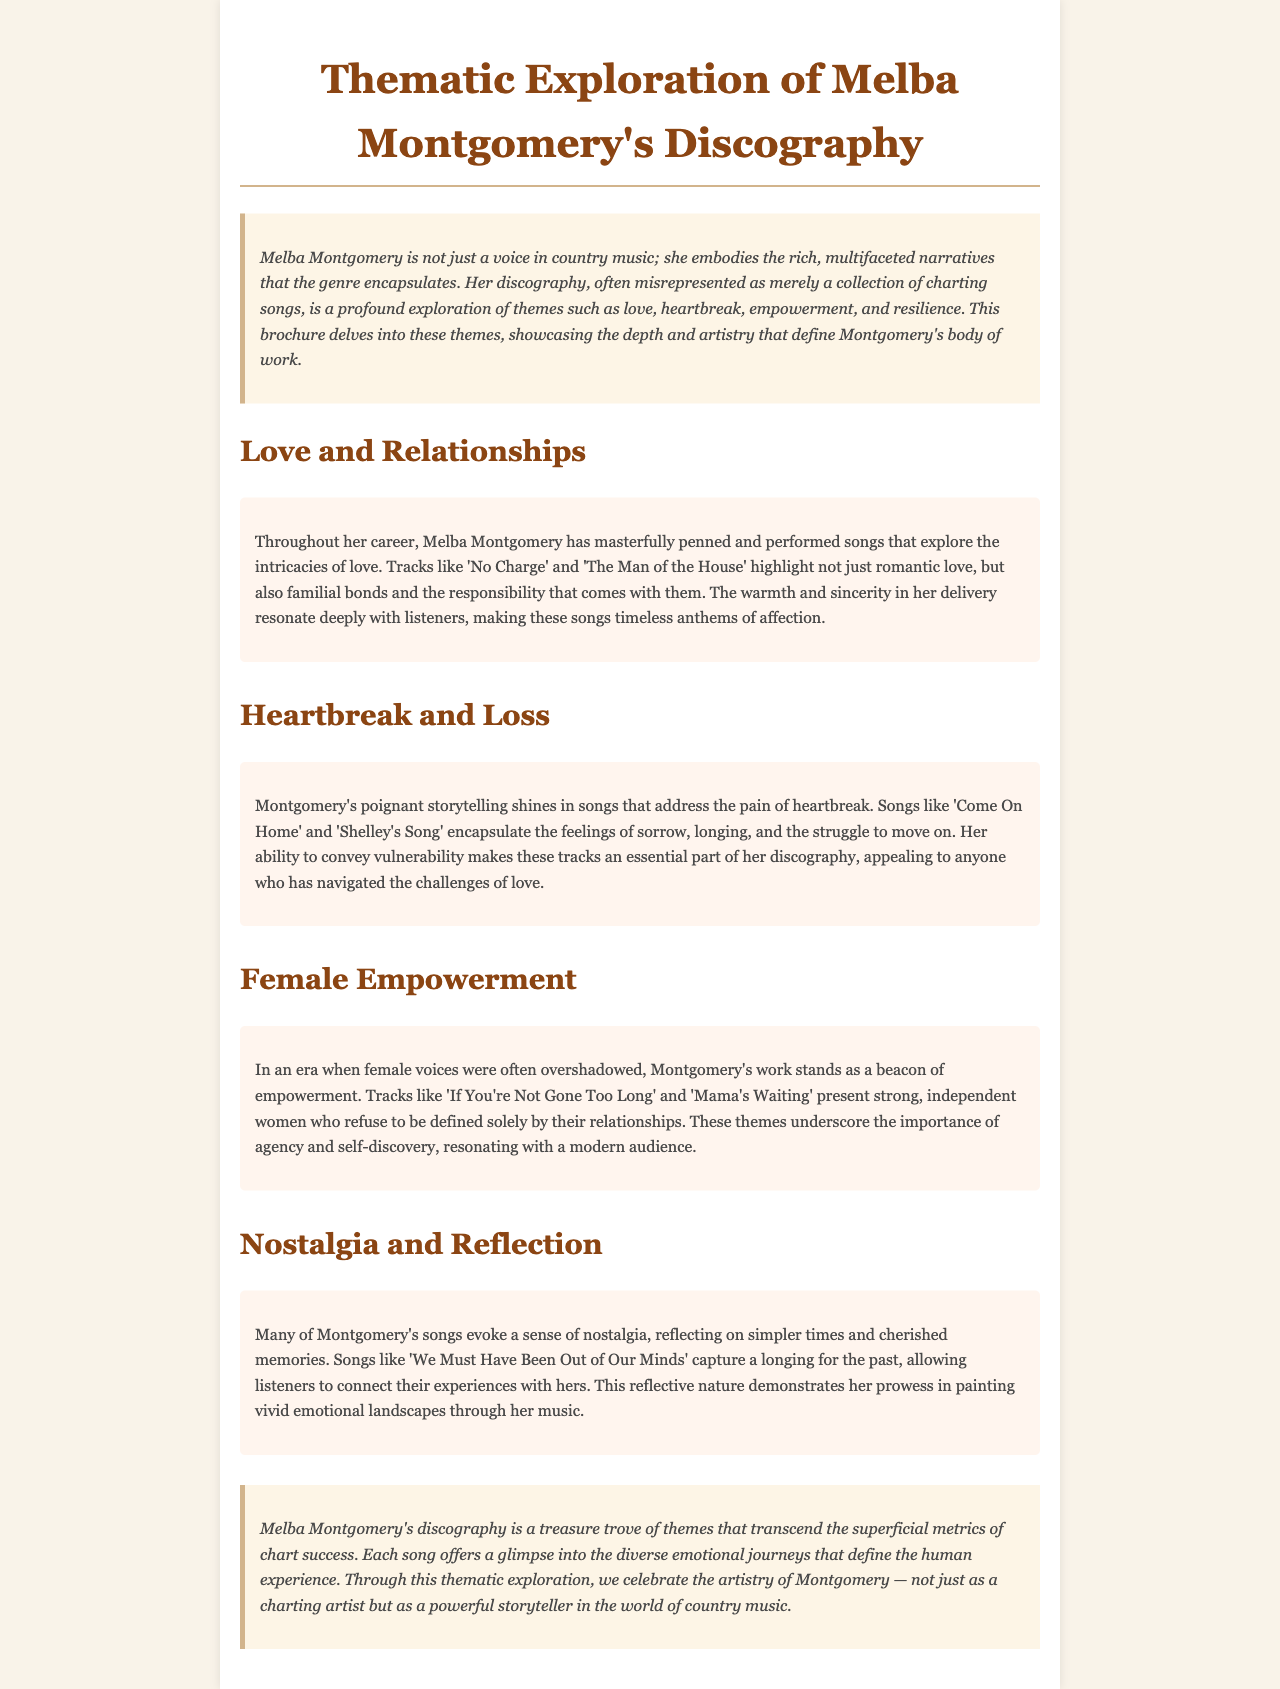What are the main themes explored in Melba Montgomery's discography? The main themes include love and relationships, heartbreak and loss, female empowerment, and nostalgia and reflection.
Answer: love and relationships, heartbreak and loss, female empowerment, nostalgia and reflection Which song addresses the theme of love? The song 'No Charge' highlights the intricacies of love as part of the theme.
Answer: No Charge What emotion is primarily captured in songs like 'Come On Home'? 'Come On Home' encapsulates feelings of sorrow and longing associated with heartbreak.
Answer: sorrow Name a song that reflects nostalgia. 'We Must Have Been Out of Our Minds' is mentioned as evoking a sense of nostalgia.
Answer: We Must Have Been Out of Our Minds How does the brochure describe Melba Montgomery's storytelling? The brochure describes her storytelling as poignant and reflective of diverse emotional journeys.
Answer: poignant What is the purpose of this brochure? The purpose is to delve into the thematic exploration of Melba Montgomery's discography.
Answer: thematic exploration Which theme is associated with the song 'If You're Not Gone Too Long'? The song 'If You're Not Gone Too Long' is associated with female empowerment.
Answer: female empowerment What does the introduction emphasize about Montgomery's discography? The introduction emphasizes that her discography is often misrepresented as merely a collection of charting songs.
Answer: misrepresented 